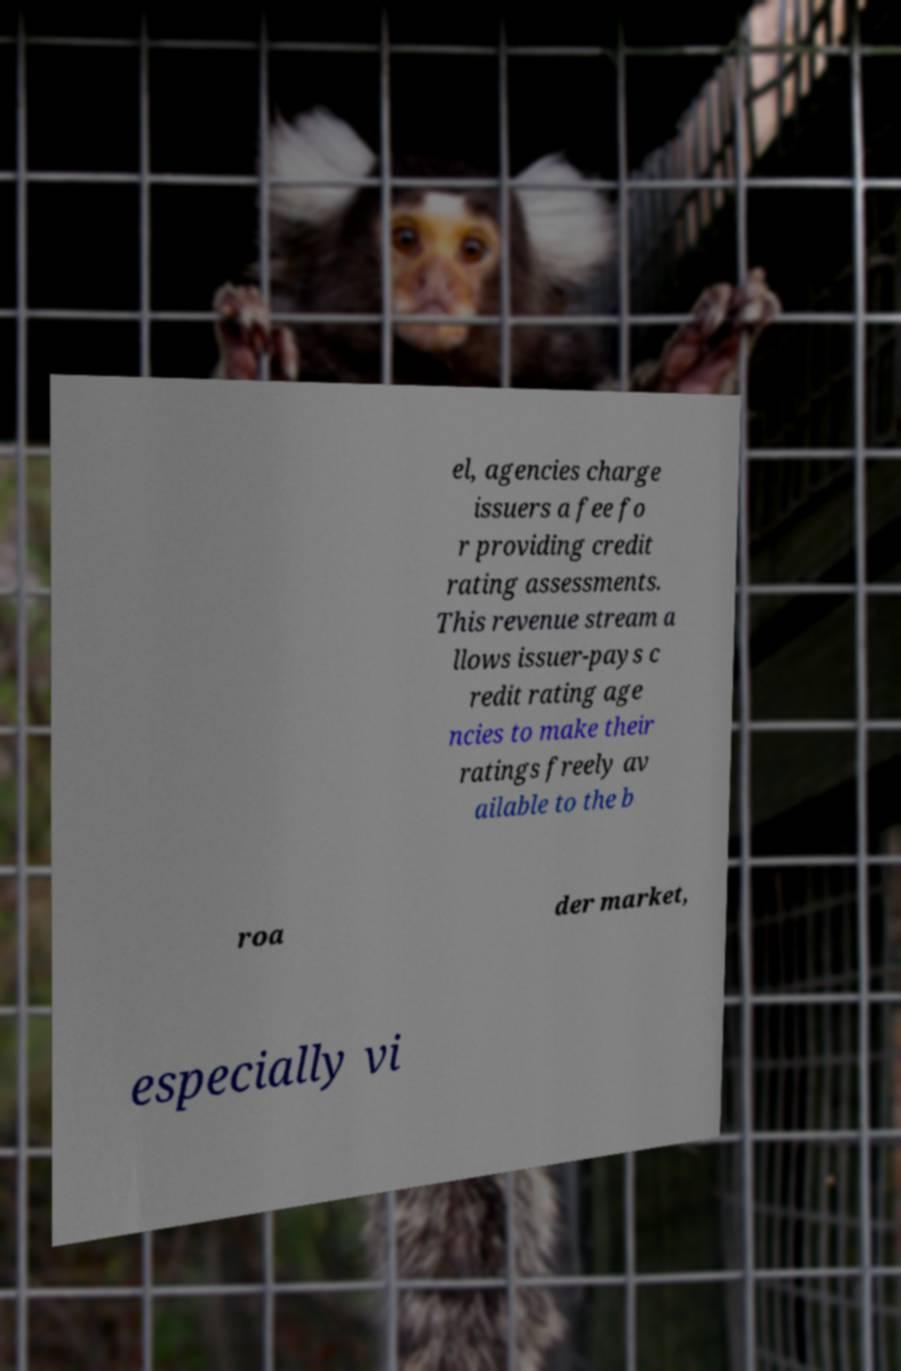Could you extract and type out the text from this image? el, agencies charge issuers a fee fo r providing credit rating assessments. This revenue stream a llows issuer-pays c redit rating age ncies to make their ratings freely av ailable to the b roa der market, especially vi 